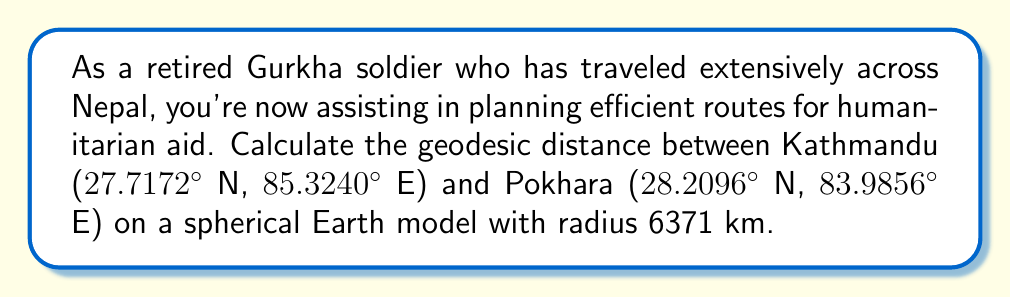Help me with this question. To calculate the geodesic distance between two points on a sphere, we use the great-circle distance formula:

$$d = R \cdot \arccos(\sin\phi_1 \sin\phi_2 + \cos\phi_1 \cos\phi_2 \cos(\lambda_2 - \lambda_1))$$

Where:
- $R$ is the Earth's radius (6371 km)
- $\phi_1, \phi_2$ are latitudes of point 1 and 2 in radians
- $\lambda_1, \lambda_2$ are longitudes of point 1 and 2 in radians

Step 1: Convert latitudes and longitudes to radians:
$\phi_1 = 27.7172° \cdot \frac{\pi}{180} = 0.4838$ rad
$\lambda_1 = 85.3240° \cdot \frac{\pi}{180} = 1.4891$ rad
$\phi_2 = 28.2096° \cdot \frac{\pi}{180} = 0.4923$ rad
$\lambda_2 = 83.9856° \cdot \frac{\pi}{180} = 1.4661$ rad

Step 2: Calculate the components inside the arccos:
$\sin\phi_1 \sin\phi_2 = \sin(0.4838) \sin(0.4923) = 0.2161$
$\cos\phi_1 \cos\phi_2 = \cos(0.4838) \cos(0.4923) = 0.7769$
$\cos(\lambda_2 - \lambda_1) = \cos(1.4661 - 1.4891) = 0.9995$

Step 3: Combine the components:
$0.2161 + 0.7769 \cdot 0.9995 = 0.9926$

Step 4: Apply the formula:
$d = 6371 \cdot \arccos(0.9926) = 6371 \cdot 0.1217 = 775.3$ km

Therefore, the geodesic distance between Kathmandu and Pokhara is approximately 775.3 km.
Answer: 775.3 km 